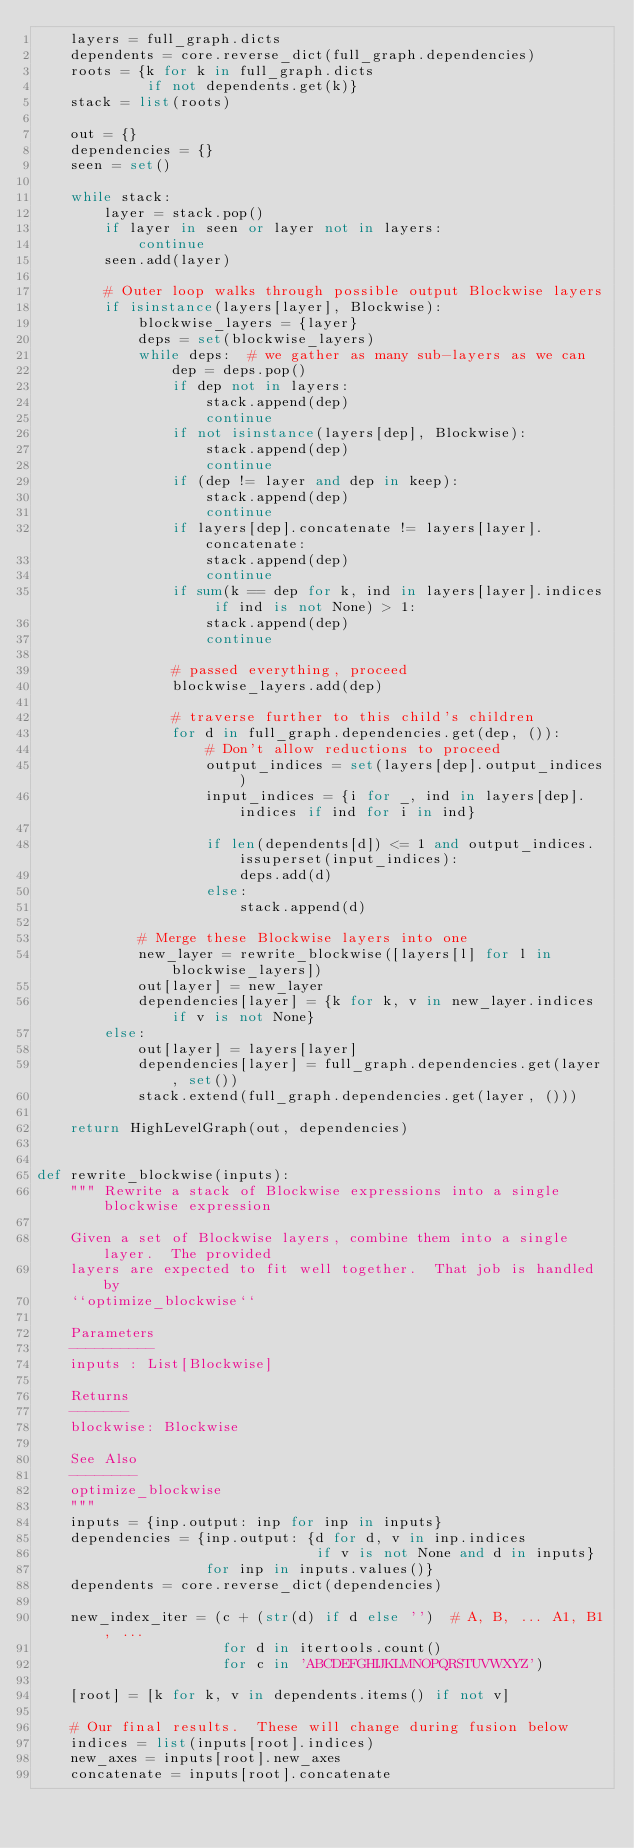Convert code to text. <code><loc_0><loc_0><loc_500><loc_500><_Python_>    layers = full_graph.dicts
    dependents = core.reverse_dict(full_graph.dependencies)
    roots = {k for k in full_graph.dicts
             if not dependents.get(k)}
    stack = list(roots)

    out = {}
    dependencies = {}
    seen = set()

    while stack:
        layer = stack.pop()
        if layer in seen or layer not in layers:
            continue
        seen.add(layer)

        # Outer loop walks through possible output Blockwise layers
        if isinstance(layers[layer], Blockwise):
            blockwise_layers = {layer}
            deps = set(blockwise_layers)
            while deps:  # we gather as many sub-layers as we can
                dep = deps.pop()
                if dep not in layers:
                    stack.append(dep)
                    continue
                if not isinstance(layers[dep], Blockwise):
                    stack.append(dep)
                    continue
                if (dep != layer and dep in keep):
                    stack.append(dep)
                    continue
                if layers[dep].concatenate != layers[layer].concatenate:
                    stack.append(dep)
                    continue
                if sum(k == dep for k, ind in layers[layer].indices if ind is not None) > 1:
                    stack.append(dep)
                    continue

                # passed everything, proceed
                blockwise_layers.add(dep)

                # traverse further to this child's children
                for d in full_graph.dependencies.get(dep, ()):
                    # Don't allow reductions to proceed
                    output_indices = set(layers[dep].output_indices)
                    input_indices = {i for _, ind in layers[dep].indices if ind for i in ind}

                    if len(dependents[d]) <= 1 and output_indices.issuperset(input_indices):
                        deps.add(d)
                    else:
                        stack.append(d)

            # Merge these Blockwise layers into one
            new_layer = rewrite_blockwise([layers[l] for l in blockwise_layers])
            out[layer] = new_layer
            dependencies[layer] = {k for k, v in new_layer.indices if v is not None}
        else:
            out[layer] = layers[layer]
            dependencies[layer] = full_graph.dependencies.get(layer, set())
            stack.extend(full_graph.dependencies.get(layer, ()))

    return HighLevelGraph(out, dependencies)


def rewrite_blockwise(inputs):
    """ Rewrite a stack of Blockwise expressions into a single blockwise expression

    Given a set of Blockwise layers, combine them into a single layer.  The provided
    layers are expected to fit well together.  That job is handled by
    ``optimize_blockwise``

    Parameters
    ----------
    inputs : List[Blockwise]

    Returns
    -------
    blockwise: Blockwise

    See Also
    --------
    optimize_blockwise
    """
    inputs = {inp.output: inp for inp in inputs}
    dependencies = {inp.output: {d for d, v in inp.indices
                                 if v is not None and d in inputs}
                    for inp in inputs.values()}
    dependents = core.reverse_dict(dependencies)

    new_index_iter = (c + (str(d) if d else '')  # A, B, ... A1, B1, ...
                      for d in itertools.count()
                      for c in 'ABCDEFGHIJKLMNOPQRSTUVWXYZ')

    [root] = [k for k, v in dependents.items() if not v]

    # Our final results.  These will change during fusion below
    indices = list(inputs[root].indices)
    new_axes = inputs[root].new_axes
    concatenate = inputs[root].concatenate</code> 